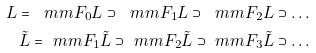Convert formula to latex. <formula><loc_0><loc_0><loc_500><loc_500>L = \ m m F _ { 0 } L \supset \ m m F _ { 1 } L \supset \ m m F _ { 2 } L \supset \dots \\ \tilde { L } = \ m m F _ { 1 } \tilde { L } \supset \ m m F _ { 2 } \tilde { L } \supset \ m m F _ { 3 } \tilde { L } \supset \dots</formula> 